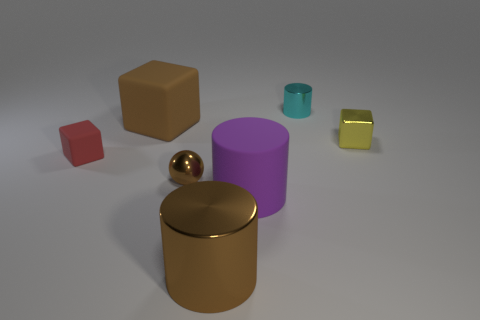What color is the big rubber object behind the tiny rubber object?
Give a very brief answer. Brown. The tiny red object is what shape?
Ensure brevity in your answer.  Cube. The tiny block in front of the tiny block behind the tiny red matte object is made of what material?
Offer a very short reply. Rubber. What number of other objects are there of the same material as the small cylinder?
Offer a terse response. 3. What is the material of the block that is the same size as the purple cylinder?
Make the answer very short. Rubber. Are there more cyan objects to the left of the purple cylinder than brown spheres behind the cyan thing?
Keep it short and to the point. No. Are there any purple metal objects of the same shape as the yellow thing?
Give a very brief answer. No. There is a red thing that is the same size as the yellow cube; what is its shape?
Your response must be concise. Cube. What shape is the big brown thing behind the small yellow cube?
Offer a very short reply. Cube. Are there fewer metal spheres that are behind the tiny brown object than purple matte cylinders behind the small yellow metal cube?
Your response must be concise. No. 